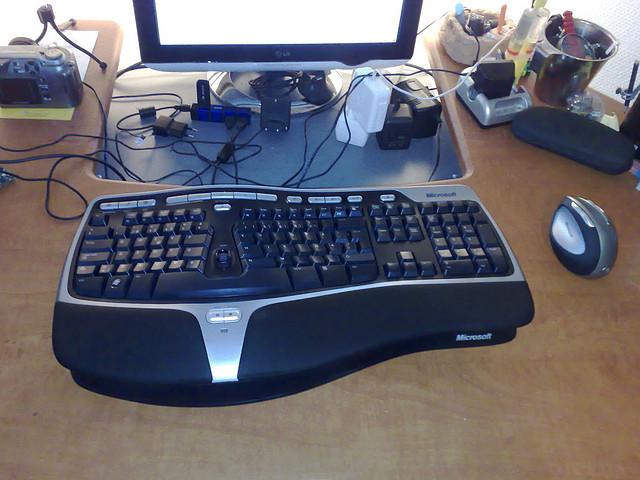Is the keyboard curved?
Short answer required. Yes. What kind of electronic is shown?
Answer briefly. Keyboard. Is there a lot of wires going on?
Keep it brief. Yes. What is laying behind the keyboard?
Write a very short answer. Wires. 